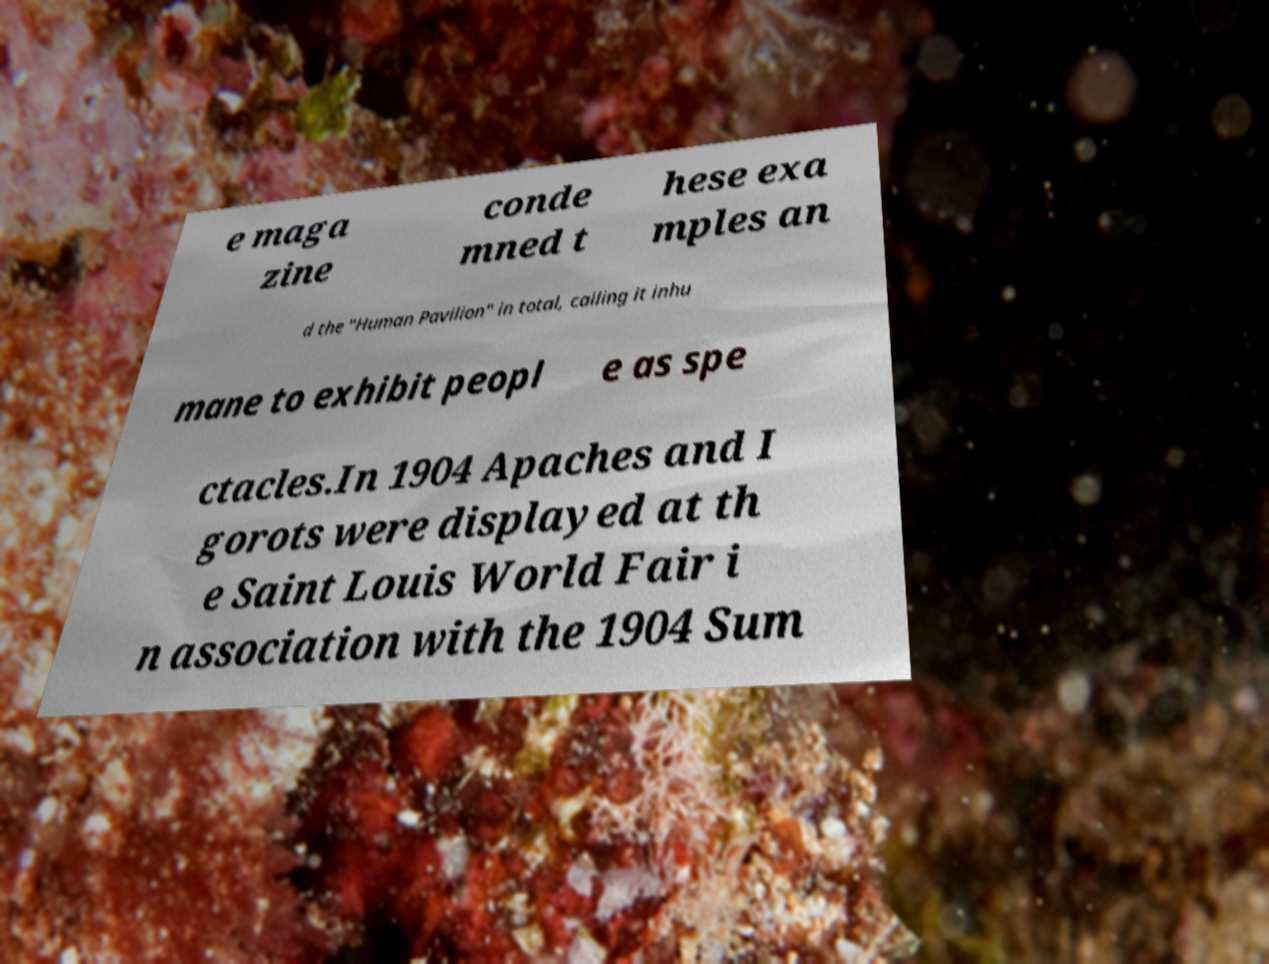For documentation purposes, I need the text within this image transcribed. Could you provide that? e maga zine conde mned t hese exa mples an d the "Human Pavilion" in total, calling it inhu mane to exhibit peopl e as spe ctacles.In 1904 Apaches and I gorots were displayed at th e Saint Louis World Fair i n association with the 1904 Sum 